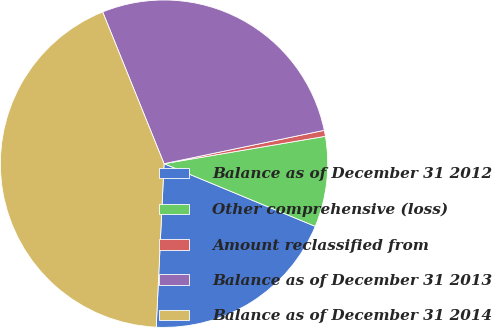Convert chart to OTSL. <chart><loc_0><loc_0><loc_500><loc_500><pie_chart><fcel>Balance as of December 31 2012<fcel>Other comprehensive (loss)<fcel>Amount reclassified from<fcel>Balance as of December 31 2013<fcel>Balance as of December 31 2014<nl><fcel>19.51%<fcel>8.93%<fcel>0.59%<fcel>27.85%<fcel>43.12%<nl></chart> 